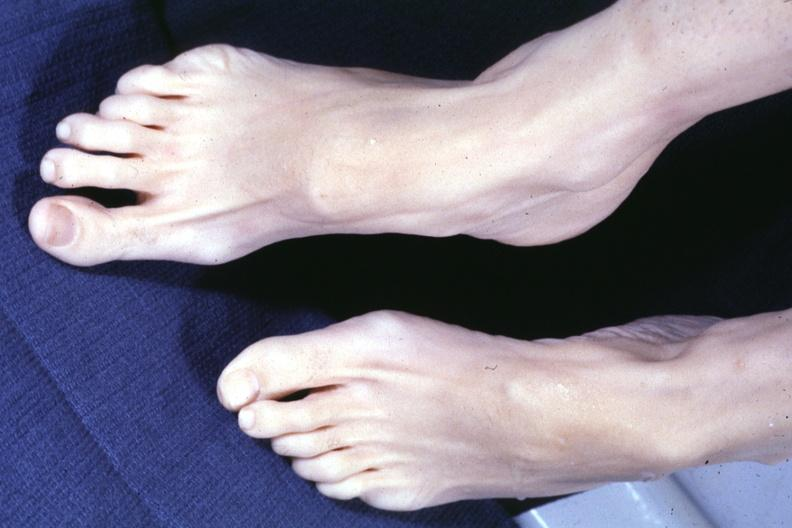what are present?
Answer the question using a single word or phrase. Extremities 